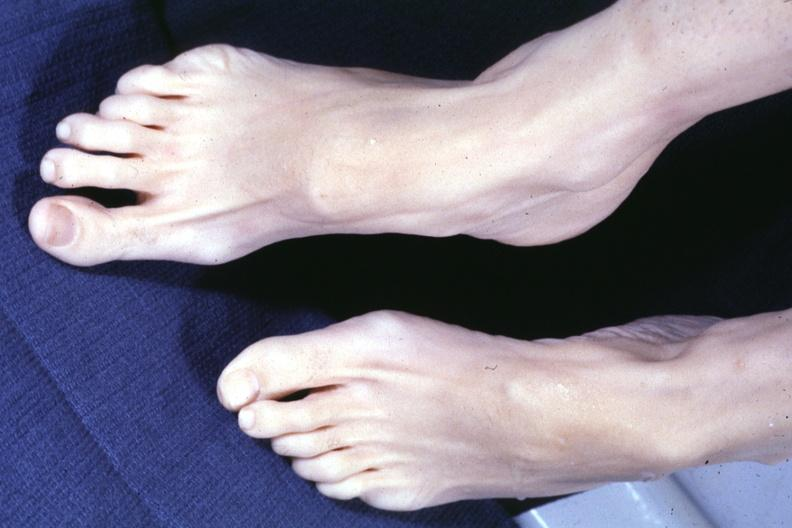what are present?
Answer the question using a single word or phrase. Extremities 